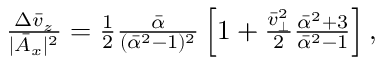<formula> <loc_0><loc_0><loc_500><loc_500>\begin{array} { r } { \frac { \Delta \bar { v } _ { z } } { | \bar { A } _ { x } | ^ { 2 } } = \frac { 1 } { 2 } \frac { \bar { \alpha } } { ( \bar { \alpha } ^ { 2 } - 1 ) ^ { 2 } } \left [ 1 + \frac { \bar { v } _ { \perp } ^ { 2 } } { 2 } \frac { \bar { \alpha } ^ { 2 } + 3 } { \bar { \alpha } ^ { 2 } - 1 } \right ] , } \end{array}</formula> 